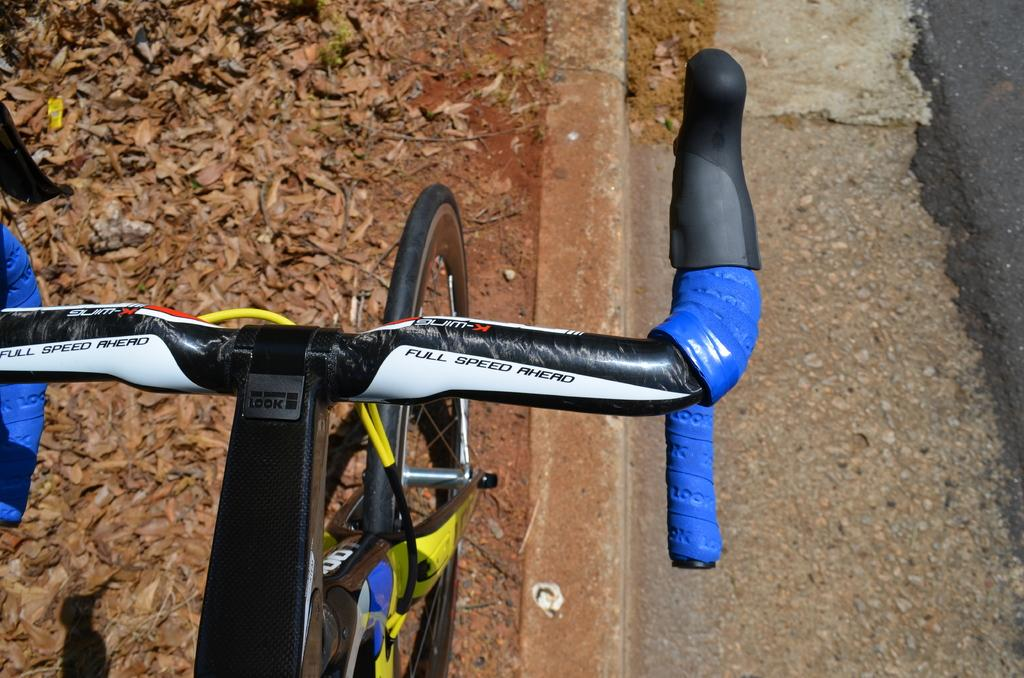What part of a bicycle can be seen in the image? There is a bicycle handle in the image. What other part of a bicycle is visible in the image? There is a bicycle wheel on the path in the image. What type of natural debris can be seen on the path in the image? Dry leaves are present on the path in the image. What type of glass can be seen in the frame of the image? There is no glass or frame present in the image; it is a photograph of a bicycle handle and wheel on a path with dry leaves. 